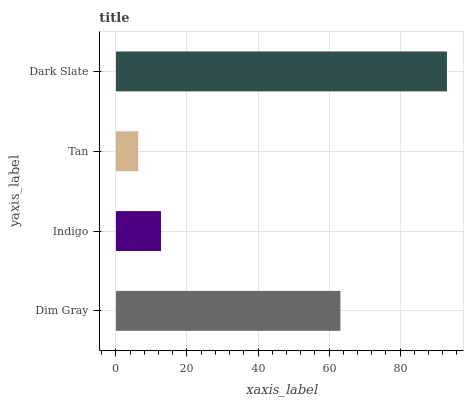Is Tan the minimum?
Answer yes or no. Yes. Is Dark Slate the maximum?
Answer yes or no. Yes. Is Indigo the minimum?
Answer yes or no. No. Is Indigo the maximum?
Answer yes or no. No. Is Dim Gray greater than Indigo?
Answer yes or no. Yes. Is Indigo less than Dim Gray?
Answer yes or no. Yes. Is Indigo greater than Dim Gray?
Answer yes or no. No. Is Dim Gray less than Indigo?
Answer yes or no. No. Is Dim Gray the high median?
Answer yes or no. Yes. Is Indigo the low median?
Answer yes or no. Yes. Is Dark Slate the high median?
Answer yes or no. No. Is Dark Slate the low median?
Answer yes or no. No. 